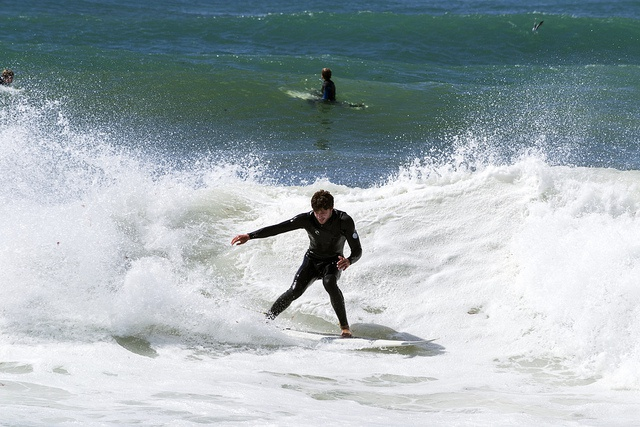Describe the objects in this image and their specific colors. I can see people in blue, black, lightgray, gray, and maroon tones, surfboard in blue, lightgray, darkgray, and gray tones, surfboard in blue, teal, black, and darkgreen tones, people in blue, black, teal, and darkgreen tones, and people in blue, gray, black, and darkgray tones in this image. 